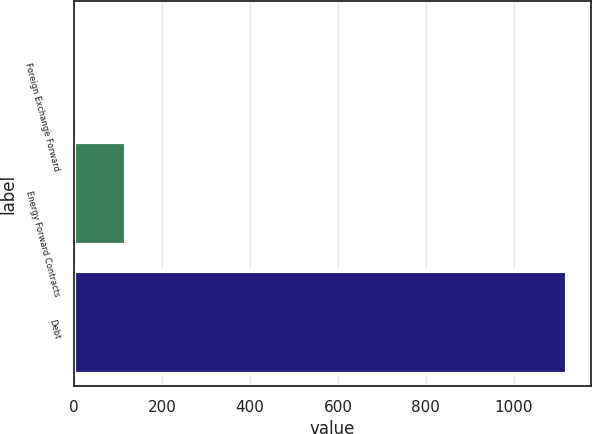<chart> <loc_0><loc_0><loc_500><loc_500><bar_chart><fcel>Foreign Exchange Forward<fcel>Energy Forward Contracts<fcel>Debt<nl><fcel>6.7<fcel>118.04<fcel>1120.1<nl></chart> 